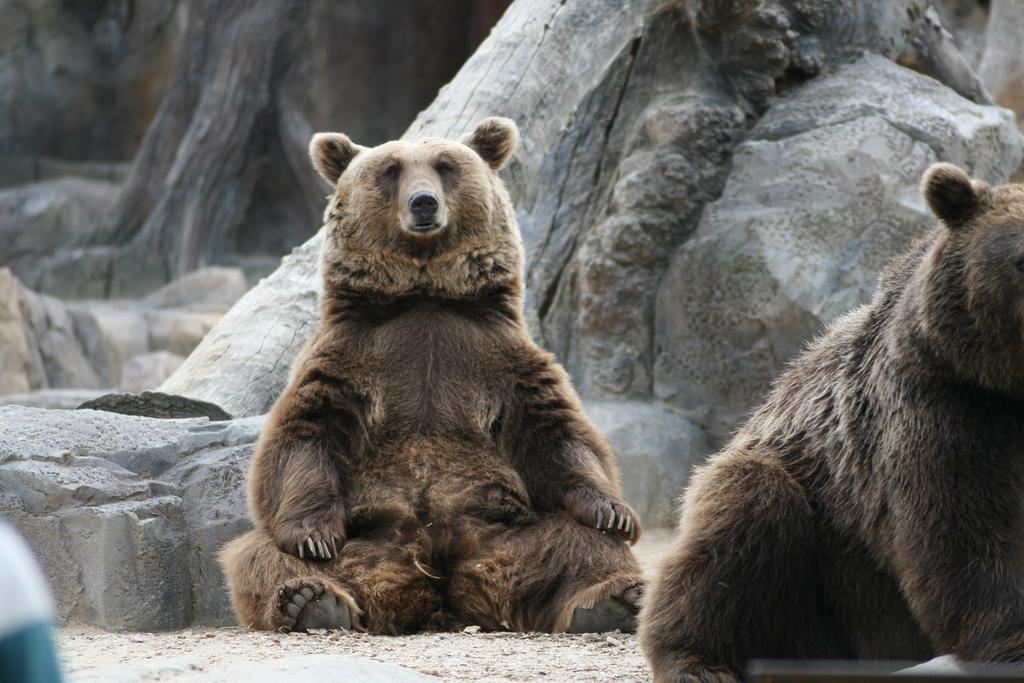What type of animal is in the image? There is a brown bear in the image. What else can be seen in the image besides the bear? There are stones visible in the image. Are there any other bears in the image? Yes, there is another bear on the right side of the image. What type of exchange is happening between the bears in the image? There is no exchange happening between the bears in the image; they are simply present in the same scene. 